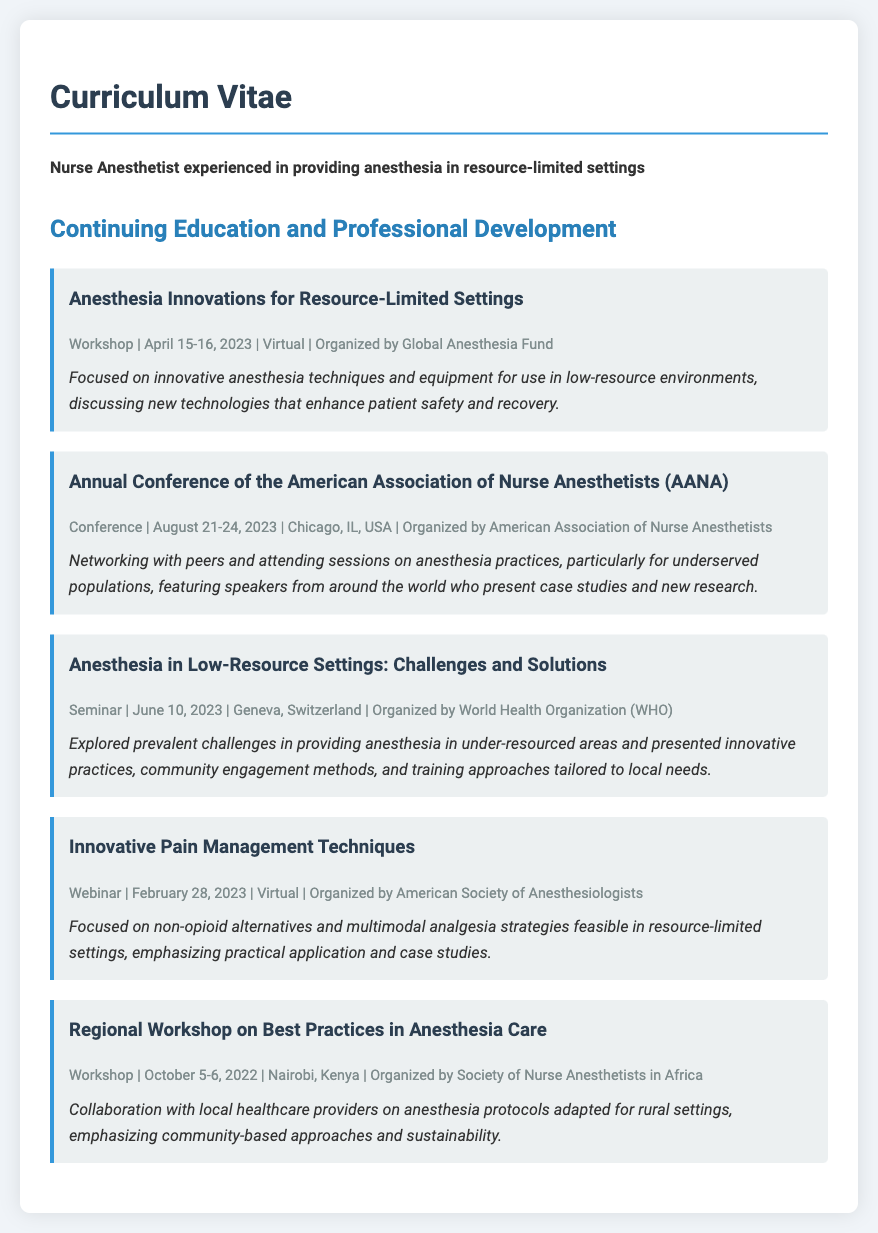What is the title of the first workshop listed? The title is mentioned at the beginning of the workshop section, which is "Anesthesia Innovations for Resource-Limited Settings."
Answer: Anesthesia Innovations for Resource-Limited Settings When did the Annual Conference of the American Association of Nurse Anesthetists take place? The event details provide specific dates, which are August 21-24, 2023.
Answer: August 21-24, 2023 Who organized the seminar on anesthesia in low-resource settings? The organizer is mentioned in the event details of the seminar, which is the World Health Organization (WHO).
Answer: World Health Organization (WHO) What type of event was held on June 10, 2023? The type of event is stated in the event details; it was a seminar.
Answer: Seminar Which country hosted the Regional Workshop on Best Practices in Anesthesia Care? The event details specify the location as Nairobi, Kenya.
Answer: Kenya What is a main focus of the Innovative Pain Management Techniques webinar? The event description highlights the focus on non-opioid alternatives and multimodal analgesia strategies.
Answer: Non-opioid alternatives and multimodal analgesia strategies How many events are listed in total in the document? The total number of events can be counted from the sections, which is five.
Answer: Five What was a significant theme discussed at the Annual Conference of the American Association of Nurse Anesthetists? The description mentions sessions on anesthesia practices for underserved populations as a key theme.
Answer: Anesthesia practices for underserved populations What was the date of the webinar on Innovative Pain Management Techniques? The event details explicitly mention the date as February 28, 2023.
Answer: February 28, 2023 